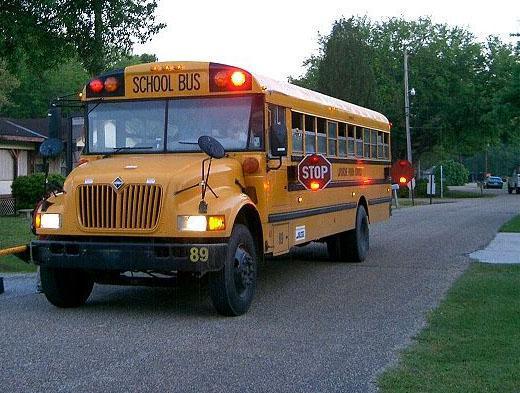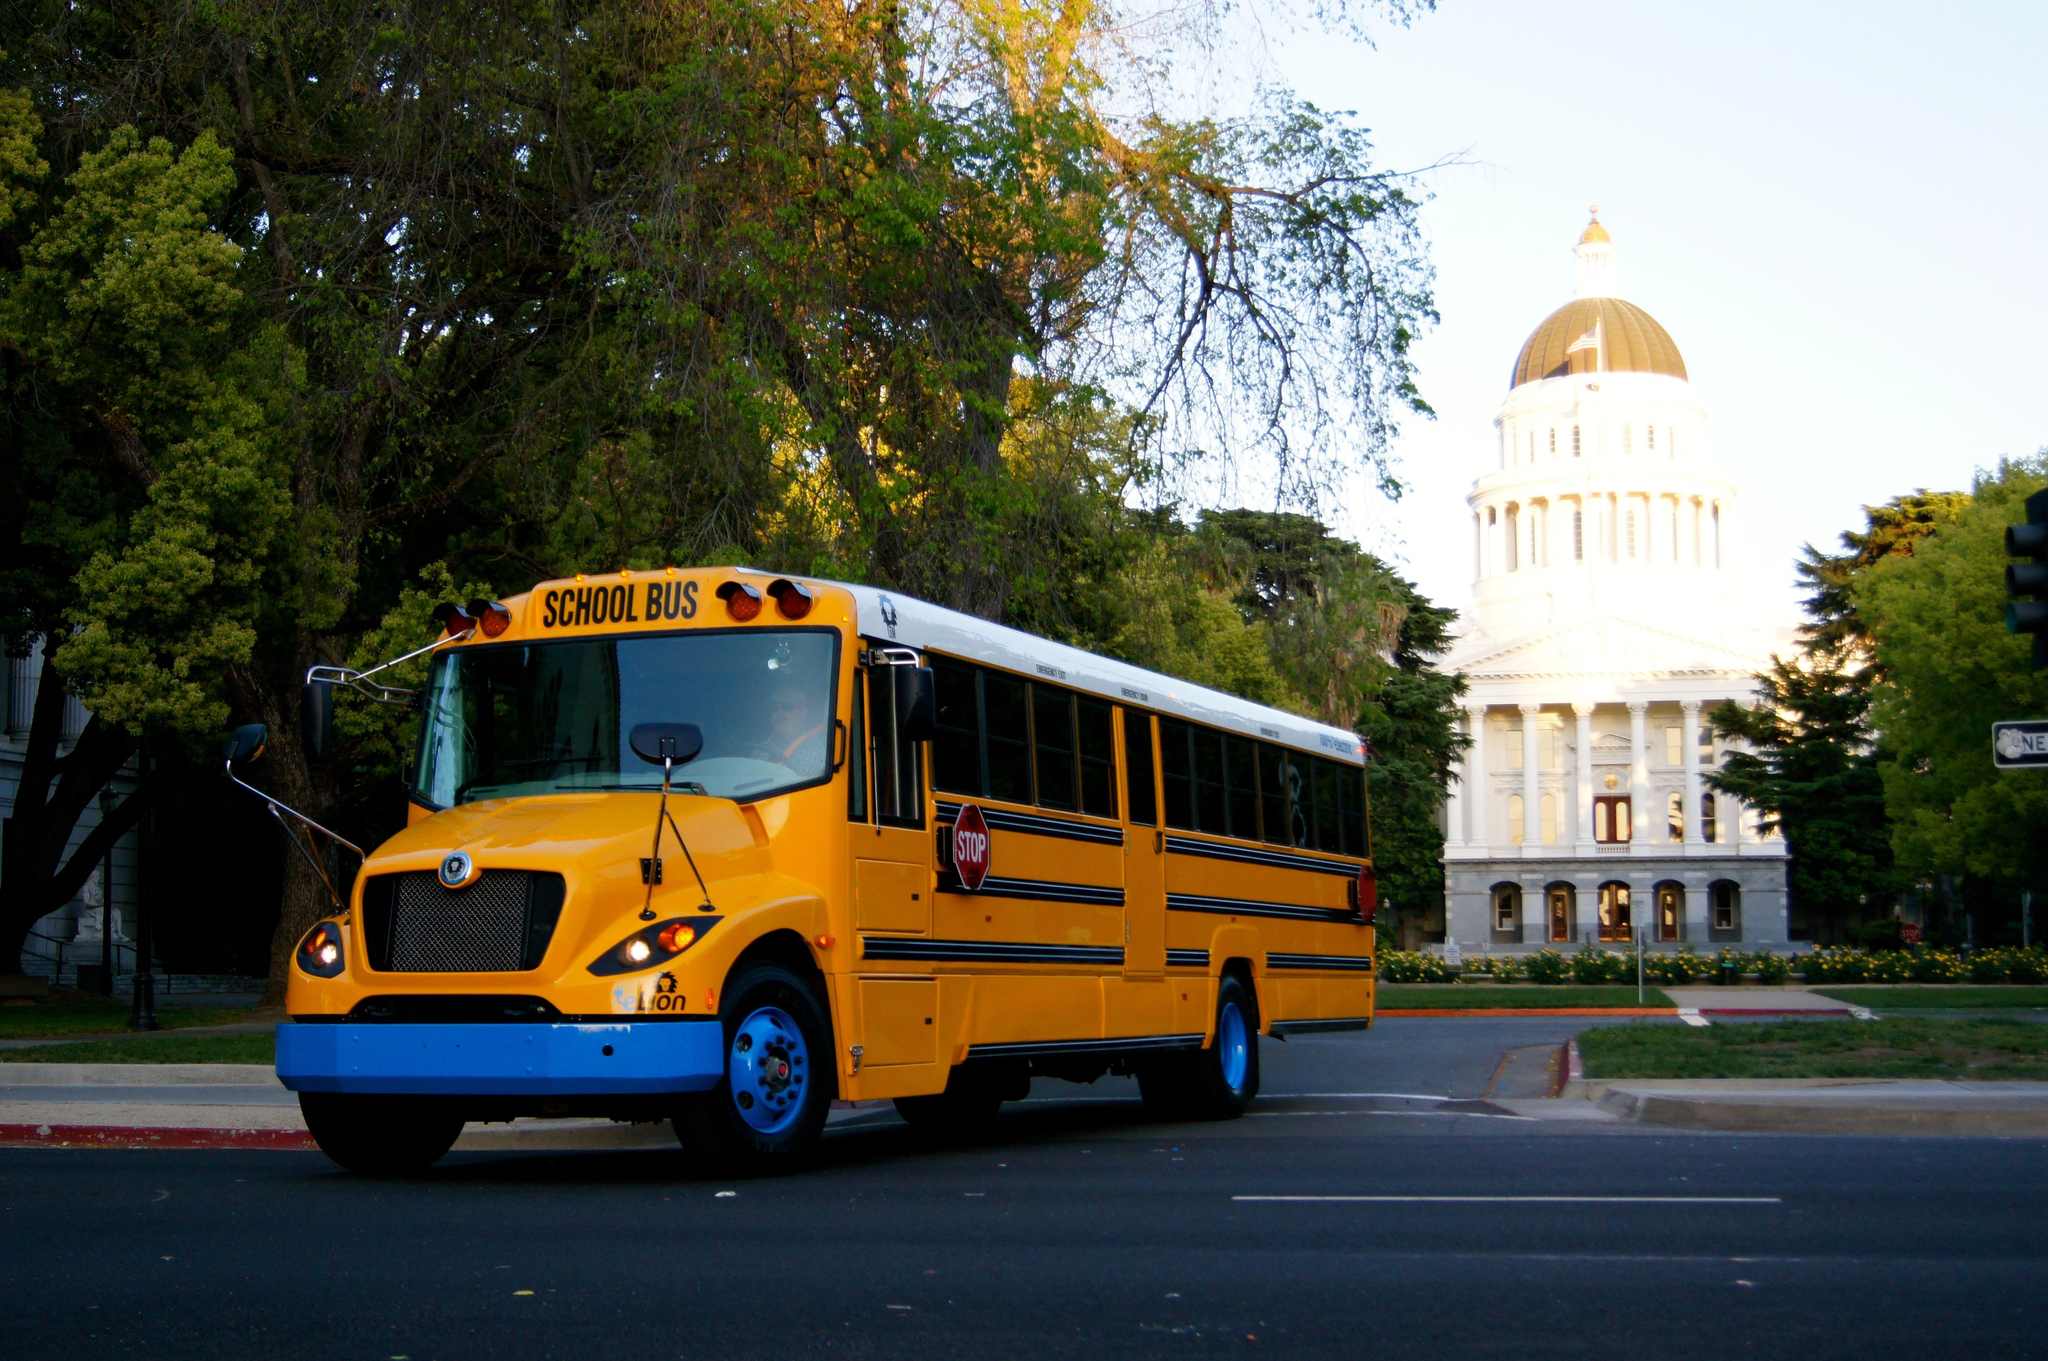The first image is the image on the left, the second image is the image on the right. For the images shown, is this caption "One of the images shows a school bus with its stop sign extended and the other image shows a school bus without an extended stop sign." true? Answer yes or no. Yes. The first image is the image on the left, the second image is the image on the right. Examine the images to the left and right. Is the description "The front of the buses in both pictures are facing the left of the picture." accurate? Answer yes or no. Yes. 